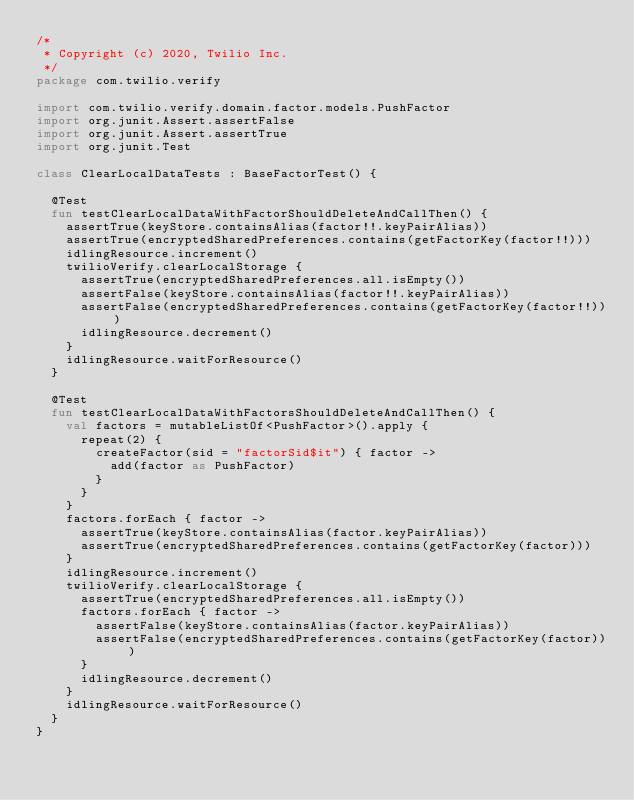Convert code to text. <code><loc_0><loc_0><loc_500><loc_500><_Kotlin_>/*
 * Copyright (c) 2020, Twilio Inc.
 */
package com.twilio.verify

import com.twilio.verify.domain.factor.models.PushFactor
import org.junit.Assert.assertFalse
import org.junit.Assert.assertTrue
import org.junit.Test

class ClearLocalDataTests : BaseFactorTest() {

  @Test
  fun testClearLocalDataWithFactorShouldDeleteAndCallThen() {
    assertTrue(keyStore.containsAlias(factor!!.keyPairAlias))
    assertTrue(encryptedSharedPreferences.contains(getFactorKey(factor!!)))
    idlingResource.increment()
    twilioVerify.clearLocalStorage {
      assertTrue(encryptedSharedPreferences.all.isEmpty())
      assertFalse(keyStore.containsAlias(factor!!.keyPairAlias))
      assertFalse(encryptedSharedPreferences.contains(getFactorKey(factor!!)))
      idlingResource.decrement()
    }
    idlingResource.waitForResource()
  }

  @Test
  fun testClearLocalDataWithFactorsShouldDeleteAndCallThen() {
    val factors = mutableListOf<PushFactor>().apply {
      repeat(2) {
        createFactor(sid = "factorSid$it") { factor ->
          add(factor as PushFactor)
        }
      }
    }
    factors.forEach { factor ->
      assertTrue(keyStore.containsAlias(factor.keyPairAlias))
      assertTrue(encryptedSharedPreferences.contains(getFactorKey(factor)))
    }
    idlingResource.increment()
    twilioVerify.clearLocalStorage {
      assertTrue(encryptedSharedPreferences.all.isEmpty())
      factors.forEach { factor ->
        assertFalse(keyStore.containsAlias(factor.keyPairAlias))
        assertFalse(encryptedSharedPreferences.contains(getFactorKey(factor)))
      }
      idlingResource.decrement()
    }
    idlingResource.waitForResource()
  }
}
</code> 